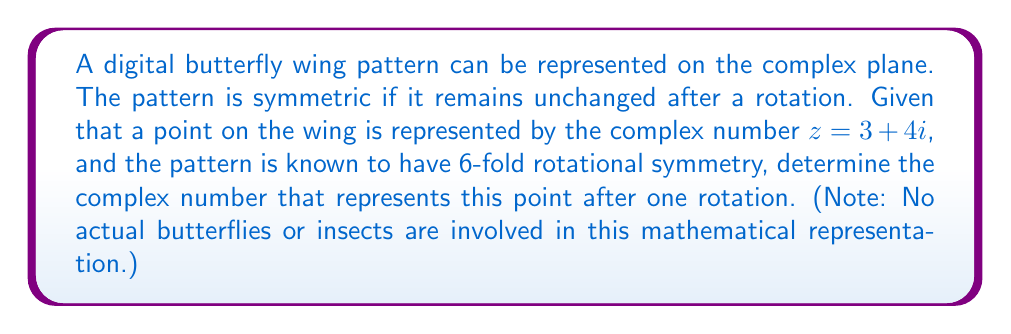Can you solve this math problem? To solve this problem, we'll follow these steps:

1) For n-fold rotational symmetry, each rotation is by an angle of $\frac{2\pi}{n}$ radians.

2) In this case, with 6-fold symmetry, the rotation angle is $\frac{2\pi}{6} = \frac{\pi}{3}$ radians.

3) To rotate a complex number by an angle $\theta$, we multiply it by $e^{i\theta}$.

4) Therefore, we need to calculate $z \cdot e^{i\frac{\pi}{3}}$.

5) Recall Euler's formula: $e^{i\theta} = \cos\theta + i\sin\theta$

6) For $\theta = \frac{\pi}{3}$:
   $e^{i\frac{\pi}{3}} = \cos\frac{\pi}{3} + i\sin\frac{\pi}{3} = \frac{1}{2} + i\frac{\sqrt{3}}{2}$

7) Now, let's multiply:
   $$(3 + 4i) \cdot (\frac{1}{2} + i\frac{\sqrt{3}}{2})$$
   
   $$= (3 \cdot \frac{1}{2} - 4 \cdot \frac{\sqrt{3}}{2}) + i(3 \cdot \frac{\sqrt{3}}{2} + 4 \cdot \frac{1}{2})$$
   
   $$= (\frac{3}{2} - 2\sqrt{3}) + i(\frac{3\sqrt{3}}{2} + 2)$$

8) Simplify:
   $$\frac{3 - 4\sqrt{3}}{2} + i(\frac{3\sqrt{3} + 4}{2})$$

This is the complex number representing the point after one rotation.
Answer: $\frac{3 - 4\sqrt{3}}{2} + i(\frac{3\sqrt{3} + 4}{2})$ 